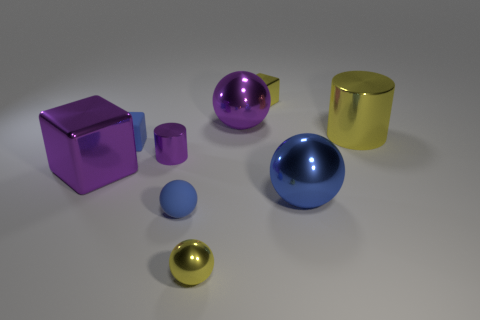Subtract all yellow balls. How many balls are left? 3 Subtract all gray cubes. How many blue spheres are left? 2 Subtract all purple balls. How many balls are left? 3 Add 1 blue metallic objects. How many objects exist? 10 Subtract all gray cubes. Subtract all blue cylinders. How many cubes are left? 3 Subtract 0 cyan balls. How many objects are left? 9 Subtract all cylinders. How many objects are left? 7 Subtract all tiny gray cubes. Subtract all blue spheres. How many objects are left? 7 Add 3 small shiny things. How many small shiny things are left? 6 Add 7 blue matte cubes. How many blue matte cubes exist? 8 